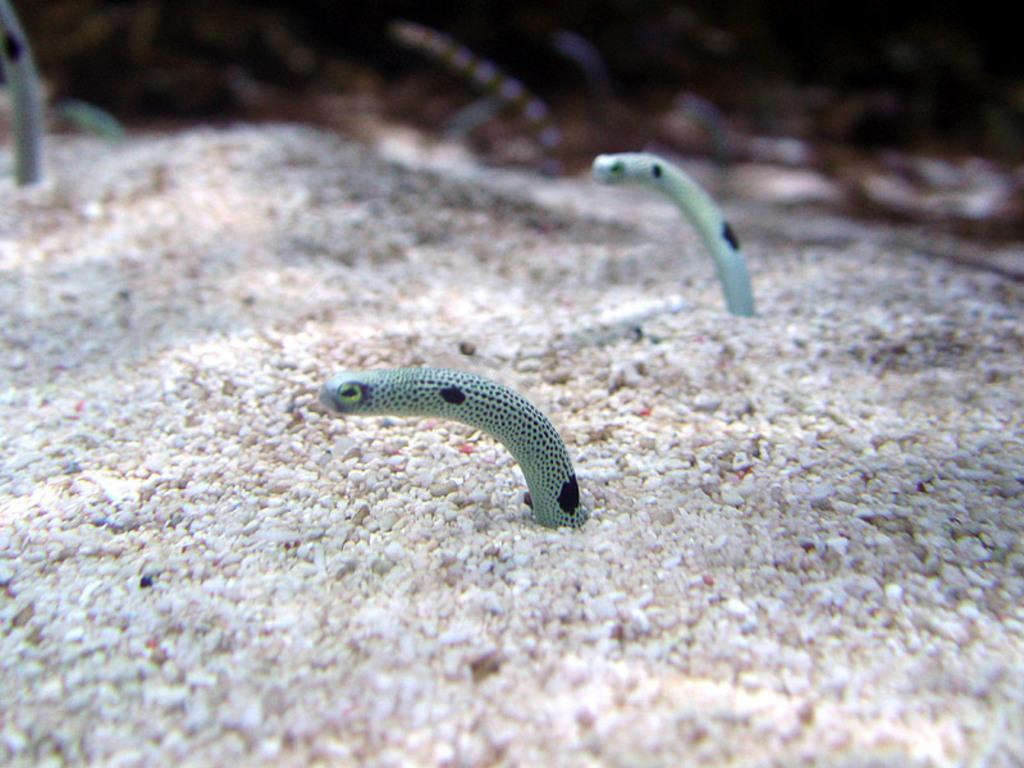What type of animals are present in the image? There are snakes in the image. Can you describe the view at the top of the image? The view at the top of the image is blurry. What type of natural elements can be seen in the image? There are stones visible in the image. What type of oatmeal is being served in the image? There is no oatmeal present in the image. How much debt is visible in the image? There is no reference to debt in the image. 